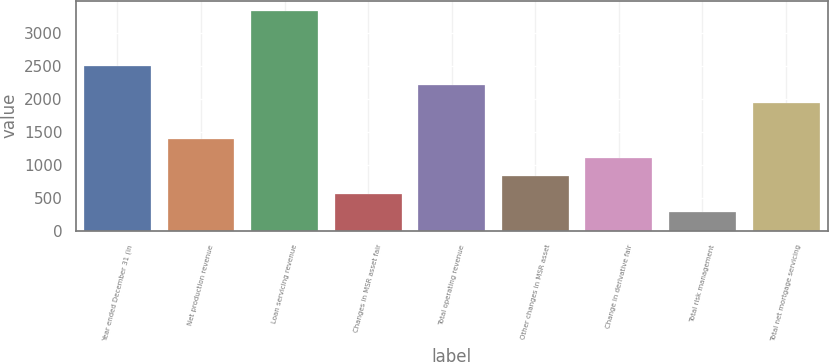<chart> <loc_0><loc_0><loc_500><loc_500><bar_chart><fcel>Year ended December 31 (in<fcel>Net production revenue<fcel>Loan servicing revenue<fcel>Changes in MSR asset fair<fcel>Total operating revenue<fcel>Other changes in MSR asset<fcel>Change in derivative fair<fcel>Total risk management<fcel>Total net mortgage servicing<nl><fcel>2498.6<fcel>1389<fcel>3330.8<fcel>556.8<fcel>2221.2<fcel>834.2<fcel>1111.6<fcel>279.4<fcel>1943.8<nl></chart> 